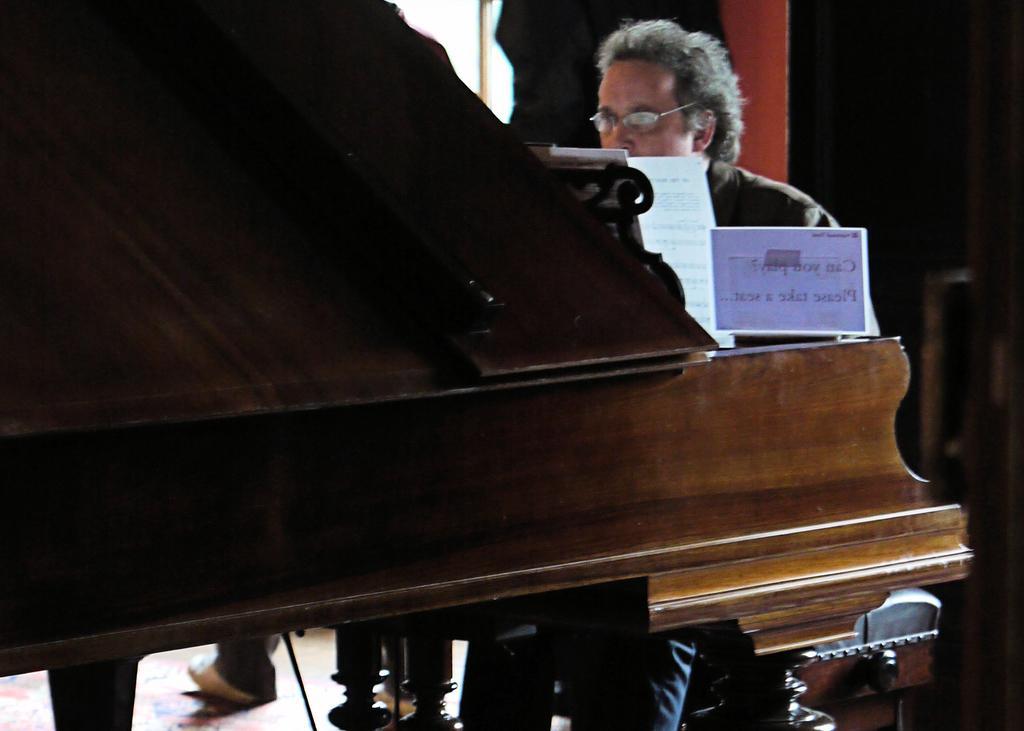Can you describe this image briefly? In this image I can see a man is sitting next to a piano set, I can also see he is wearing a specs. 